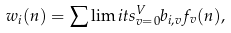Convert formula to latex. <formula><loc_0><loc_0><loc_500><loc_500>w _ { i } ( n ) = \sum \lim i t s ^ { V } _ { v = 0 } { b _ { i , v } f _ { v } ( n ) } ,</formula> 